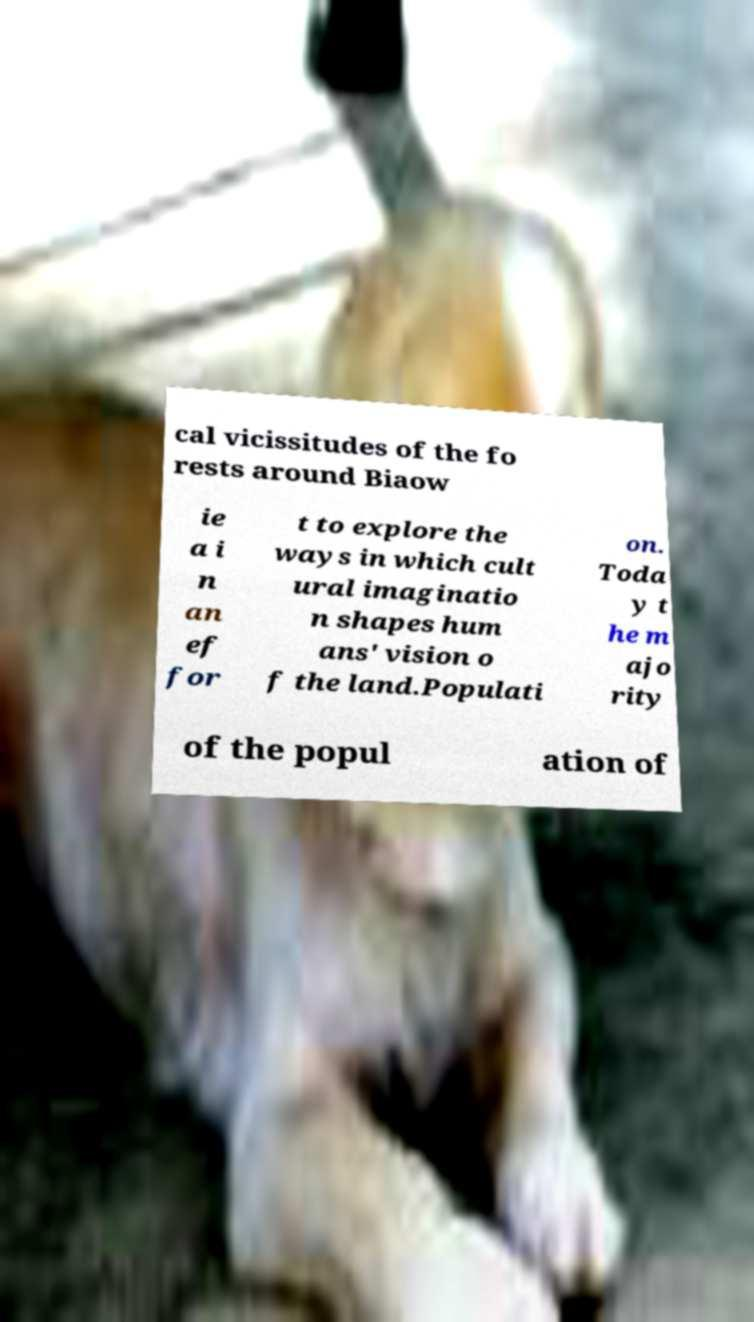Can you read and provide the text displayed in the image?This photo seems to have some interesting text. Can you extract and type it out for me? cal vicissitudes of the fo rests around Biaow ie a i n an ef for t to explore the ways in which cult ural imaginatio n shapes hum ans' vision o f the land.Populati on. Toda y t he m ajo rity of the popul ation of 